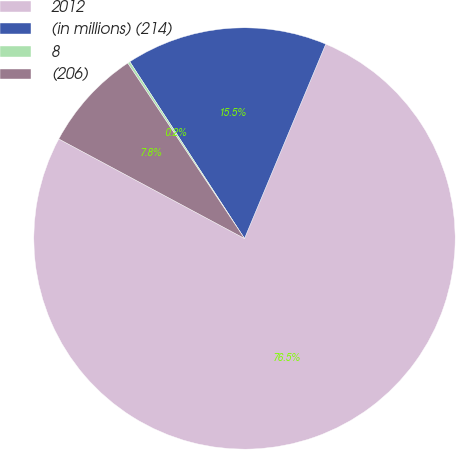<chart> <loc_0><loc_0><loc_500><loc_500><pie_chart><fcel>2012<fcel>(in millions) (214)<fcel>8<fcel>(206)<nl><fcel>76.53%<fcel>15.46%<fcel>0.19%<fcel>7.82%<nl></chart> 